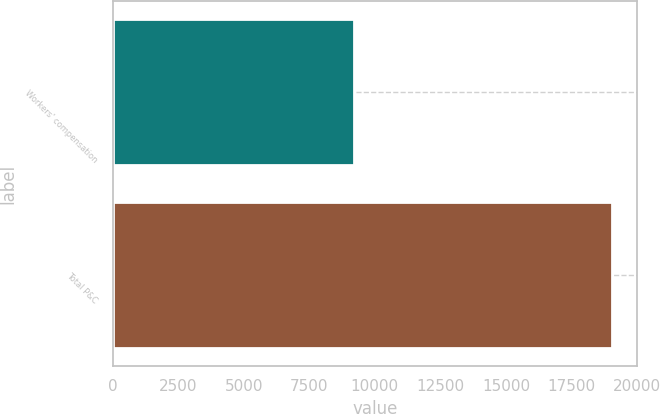Convert chart to OTSL. <chart><loc_0><loc_0><loc_500><loc_500><bar_chart><fcel>Workers' compensation<fcel>Total P&C<nl><fcel>9189<fcel>19057<nl></chart> 